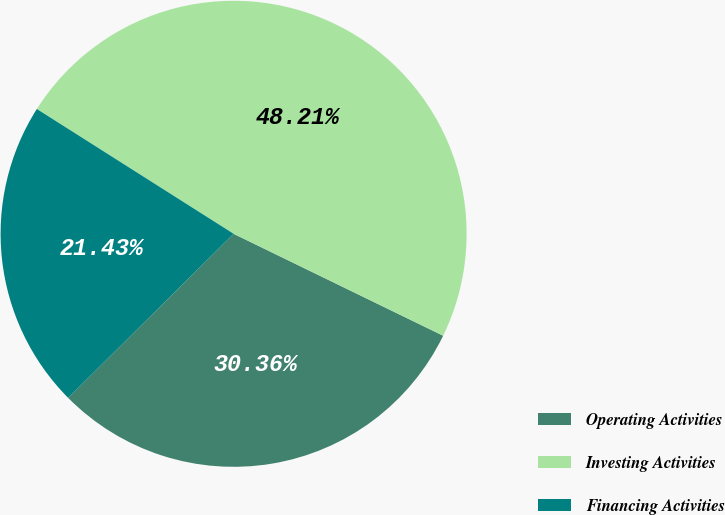Convert chart to OTSL. <chart><loc_0><loc_0><loc_500><loc_500><pie_chart><fcel>Operating Activities<fcel>Investing Activities<fcel>Financing Activities<nl><fcel>30.36%<fcel>48.21%<fcel>21.43%<nl></chart> 